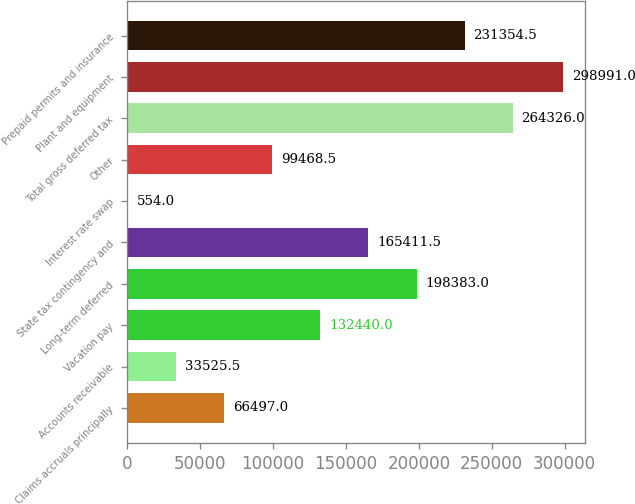Convert chart to OTSL. <chart><loc_0><loc_0><loc_500><loc_500><bar_chart><fcel>Claims accruals principally<fcel>Accounts receivable<fcel>Vacation pay<fcel>Long-term deferred<fcel>State tax contingency and<fcel>Interest rate swap<fcel>Other<fcel>Total gross deferred tax<fcel>Plant and equipment<fcel>Prepaid permits and insurance<nl><fcel>66497<fcel>33525.5<fcel>132440<fcel>198383<fcel>165412<fcel>554<fcel>99468.5<fcel>264326<fcel>298991<fcel>231354<nl></chart> 